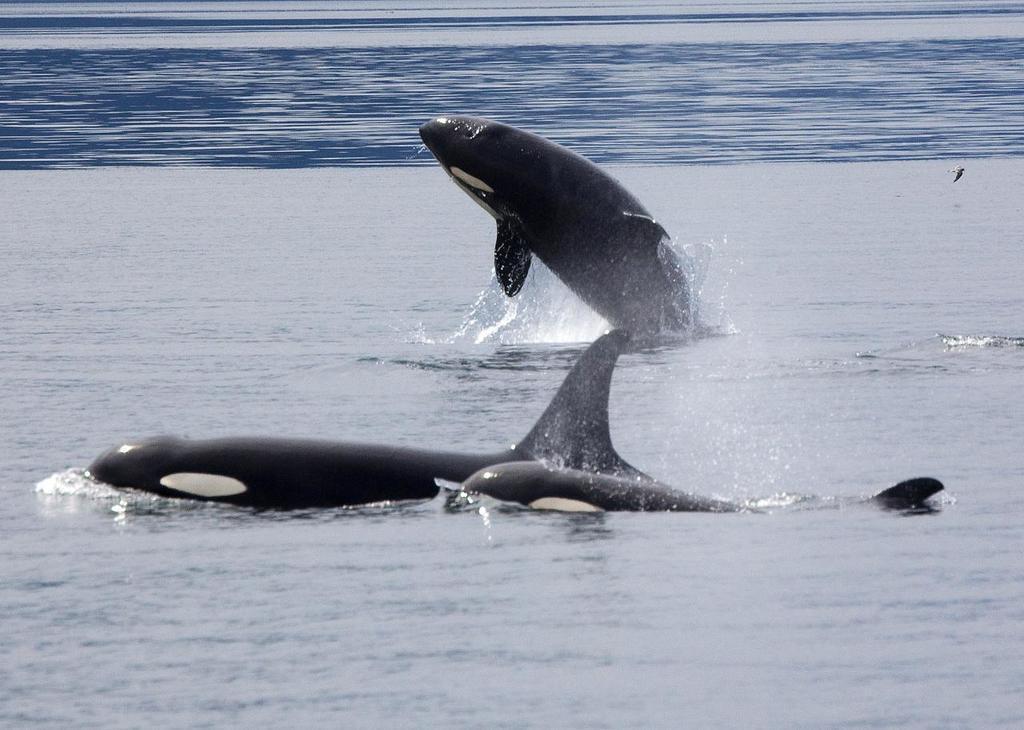In one or two sentences, can you explain what this image depicts? In this image, I can see three dolphins in the water. I can see one of the dolphin is jumping from the water. This looks like a sea. I can see a tiny bird flying. 